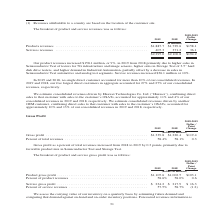According to Teradyne's financial document, What was the change in product revenues? According to the financial document, $158.1 million. The relevant text states: "Our product revenues increased $158.1 million, or 9%, in 2019 from 2018 primarily due to higher sales in Semiconductor Test of testers for 5G inf..." Also, What was the change in services revenues? According to the financial document, $36.1 million. The relevant text states: "d analog test segments. Service revenues increased $36.1 million or 10%...." Also, What are the components comprising total revenue? The document shows two values: Products revenues and Services revenues. From the document: "(in millions) Products revenues . $1,887.7 $1,729.6 $158.1 Services revenues . 407.3 371.2 36.1 ons) Products revenues . $1,887.7 $1,729.6 $158.1 Serv..." Additionally, In which year was the amount of services revenues larger? According to the financial document, 2019. The relevant text states: "2019 2018..." Also, can you calculate: What was the percentage change in total revenues from 2018 to 2019? To answer this question, I need to perform calculations using the financial data. The calculation is: (2,295.0-2,100.8)/2,100.8, which equals 9.24 (percentage). This is based on the information: "$2,295.0 $2,100.8 $194.2 $2,295.0 $2,100.8 $194.2..." The key data points involved are: 2,100.8, 2,295.0. Also, can you calculate: What was the average services revenues in 2018 and 2019? To answer this question, I need to perform calculations using the financial data. The calculation is: (407.3+371.2)/2, which equals 389.25 (in millions). This is based on the information: "1,887.7 $1,729.6 $158.1 Services revenues . 407.3 371.2 36.1 es . $1,887.7 $1,729.6 $158.1 Services revenues . 407.3 371.2 36.1..." The key data points involved are: 371.2, 407.3. 